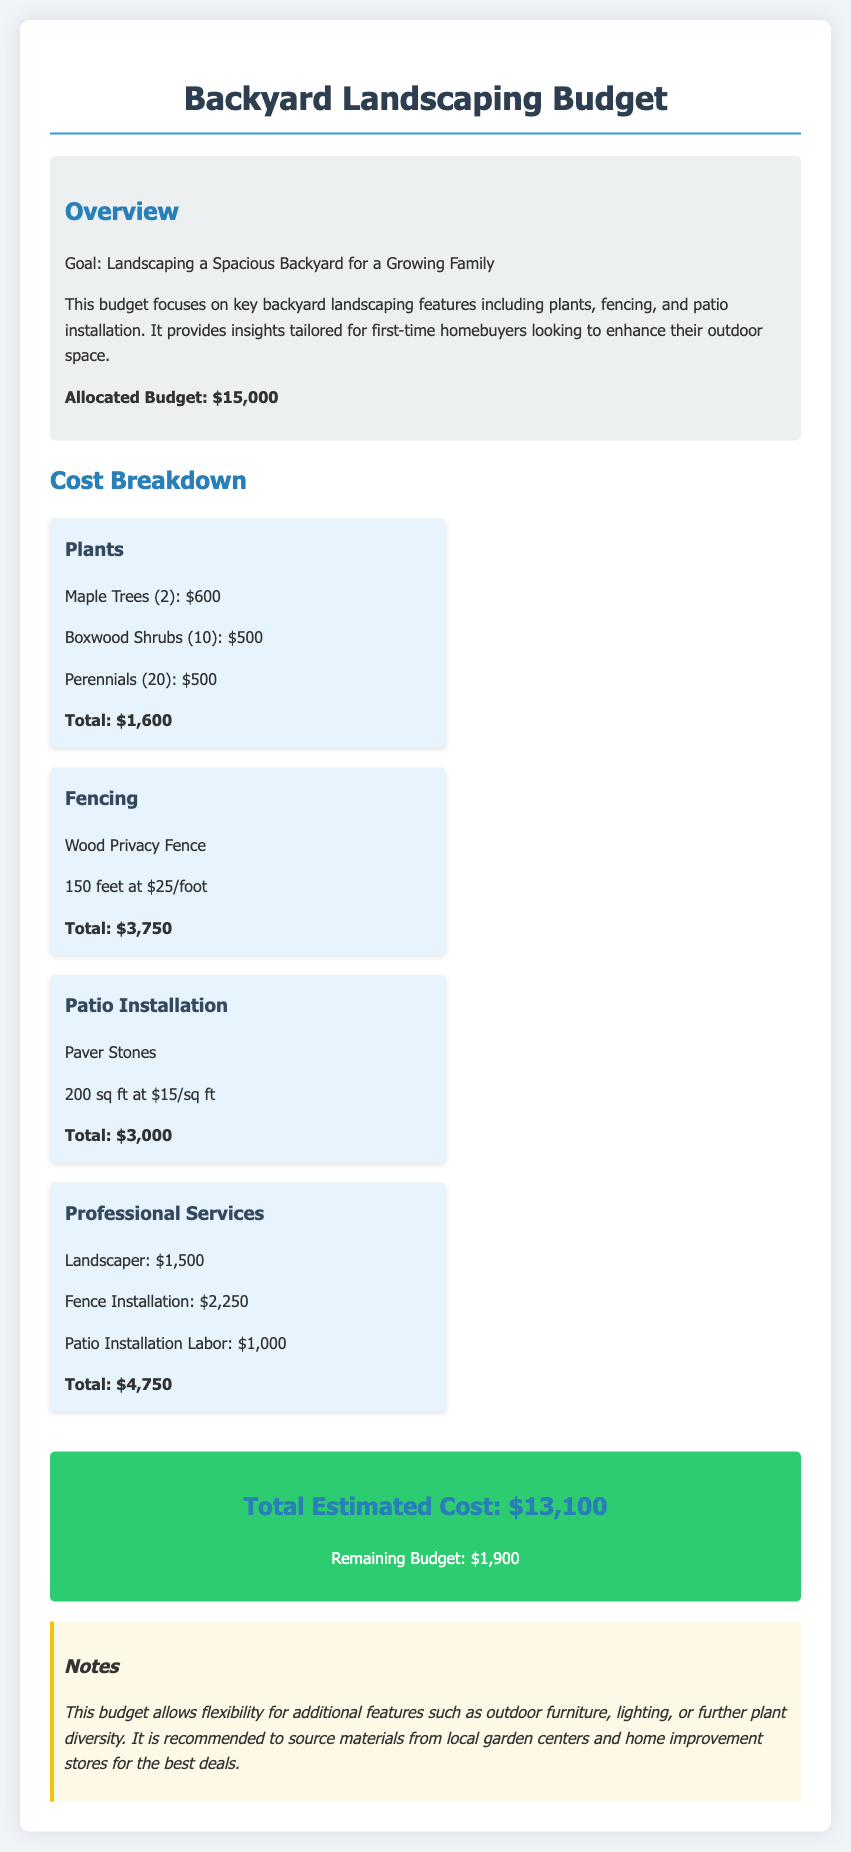What is the allocated budget for landscaping? The allocated budget for landscaping is stated clearly in the document.
Answer: $15,000 How much do the Maple Trees cost? The cost of the Maple Trees is listed in the cost breakdown section of the document.
Answer: $600 What is the total cost for plants? The total cost for all plants is summarized in the plants section of the budget.
Answer: $1,600 How long is the wood privacy fence? The length of the wood privacy fence is mentioned in the fencing section of the budget.
Answer: 150 feet What is the total estimated cost after the breakdown? The total estimated cost is provided in the total cost section, summarizing all expenses.
Answer: $13,100 What is the remaining budget after landscaping expenses? The remaining budget is calculated and stated at the end of the budget document.
Answer: $1,900 What type of fence is being installed? The document specifies the type of fencing included in the landscaping budget.
Answer: Wood Privacy Fence How much does it cost to install the patio per square foot? The cost per square foot for patio installation is mentioned in the relevant section.
Answer: $15 How much does the landscaper charge? The charge for the landscaper is provided in the professional services section of the budget.
Answer: $1,500 What additional features are suggested for flexibility in the budget? The notes section mentions potential additional features for flexibility in the budget.
Answer: Outdoor furniture, lighting, or further plant diversity 